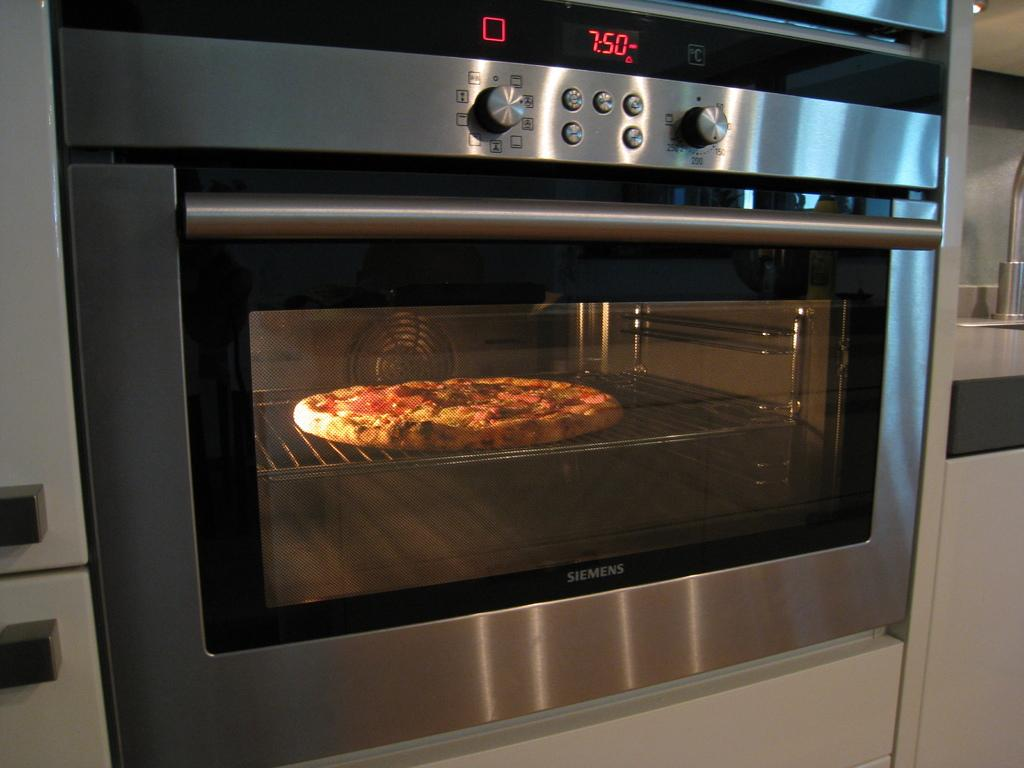<image>
Write a terse but informative summary of the picture. An oven with a pizza in it set to 7:50. 